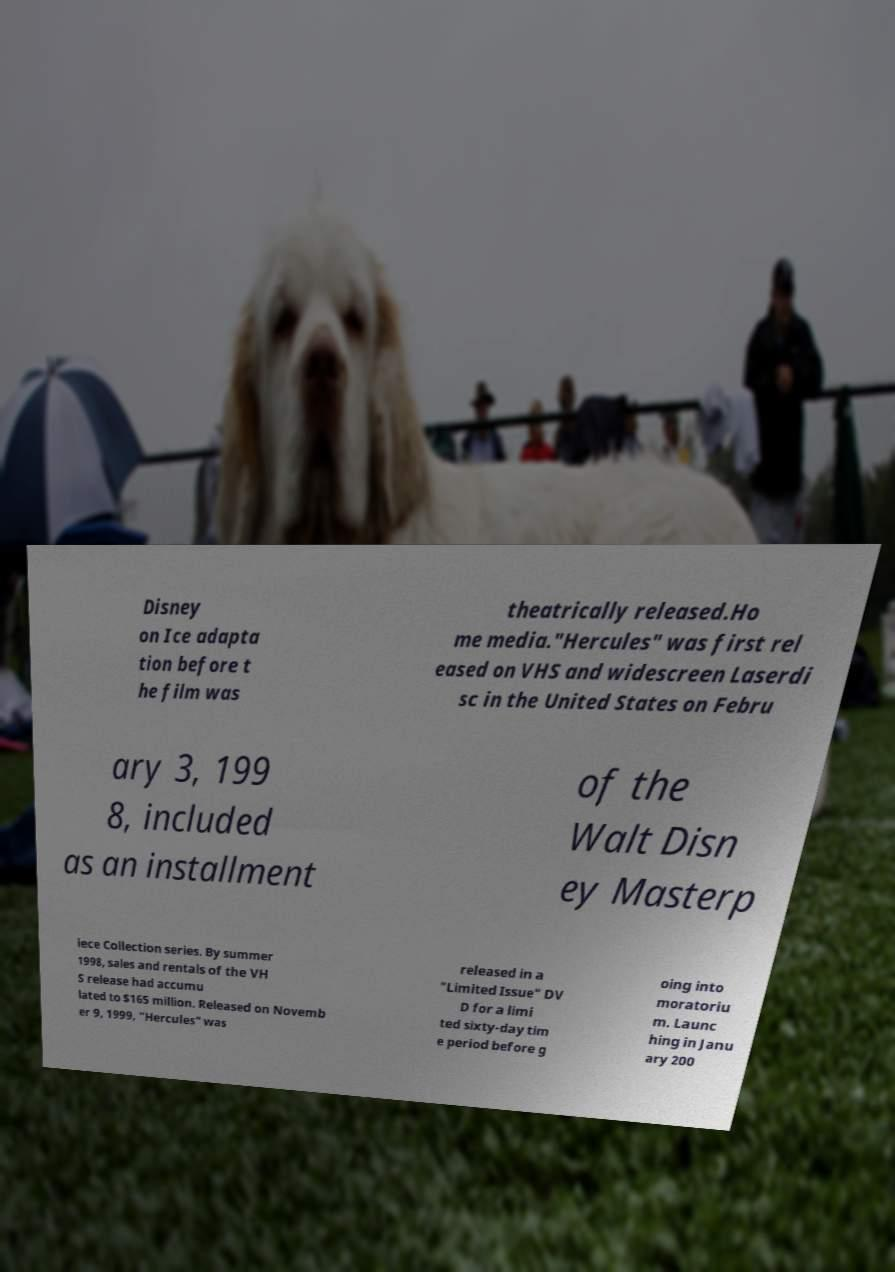Please identify and transcribe the text found in this image. Disney on Ice adapta tion before t he film was theatrically released.Ho me media."Hercules" was first rel eased on VHS and widescreen Laserdi sc in the United States on Febru ary 3, 199 8, included as an installment of the Walt Disn ey Masterp iece Collection series. By summer 1998, sales and rentals of the VH S release had accumu lated to $165 million. Released on Novemb er 9, 1999, "Hercules" was released in a "Limited Issue" DV D for a limi ted sixty-day tim e period before g oing into moratoriu m. Launc hing in Janu ary 200 